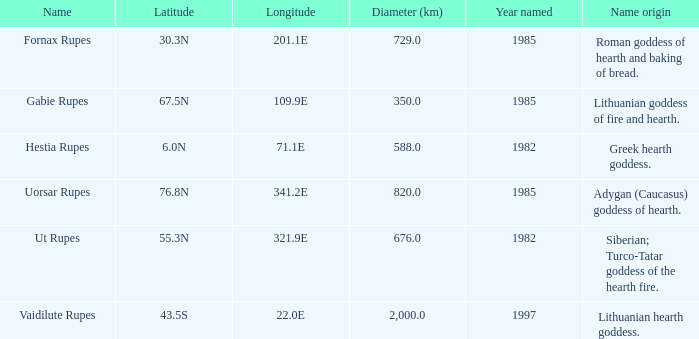What is the latitudinal coordinate of vaidilute rupes? 43.5S. 